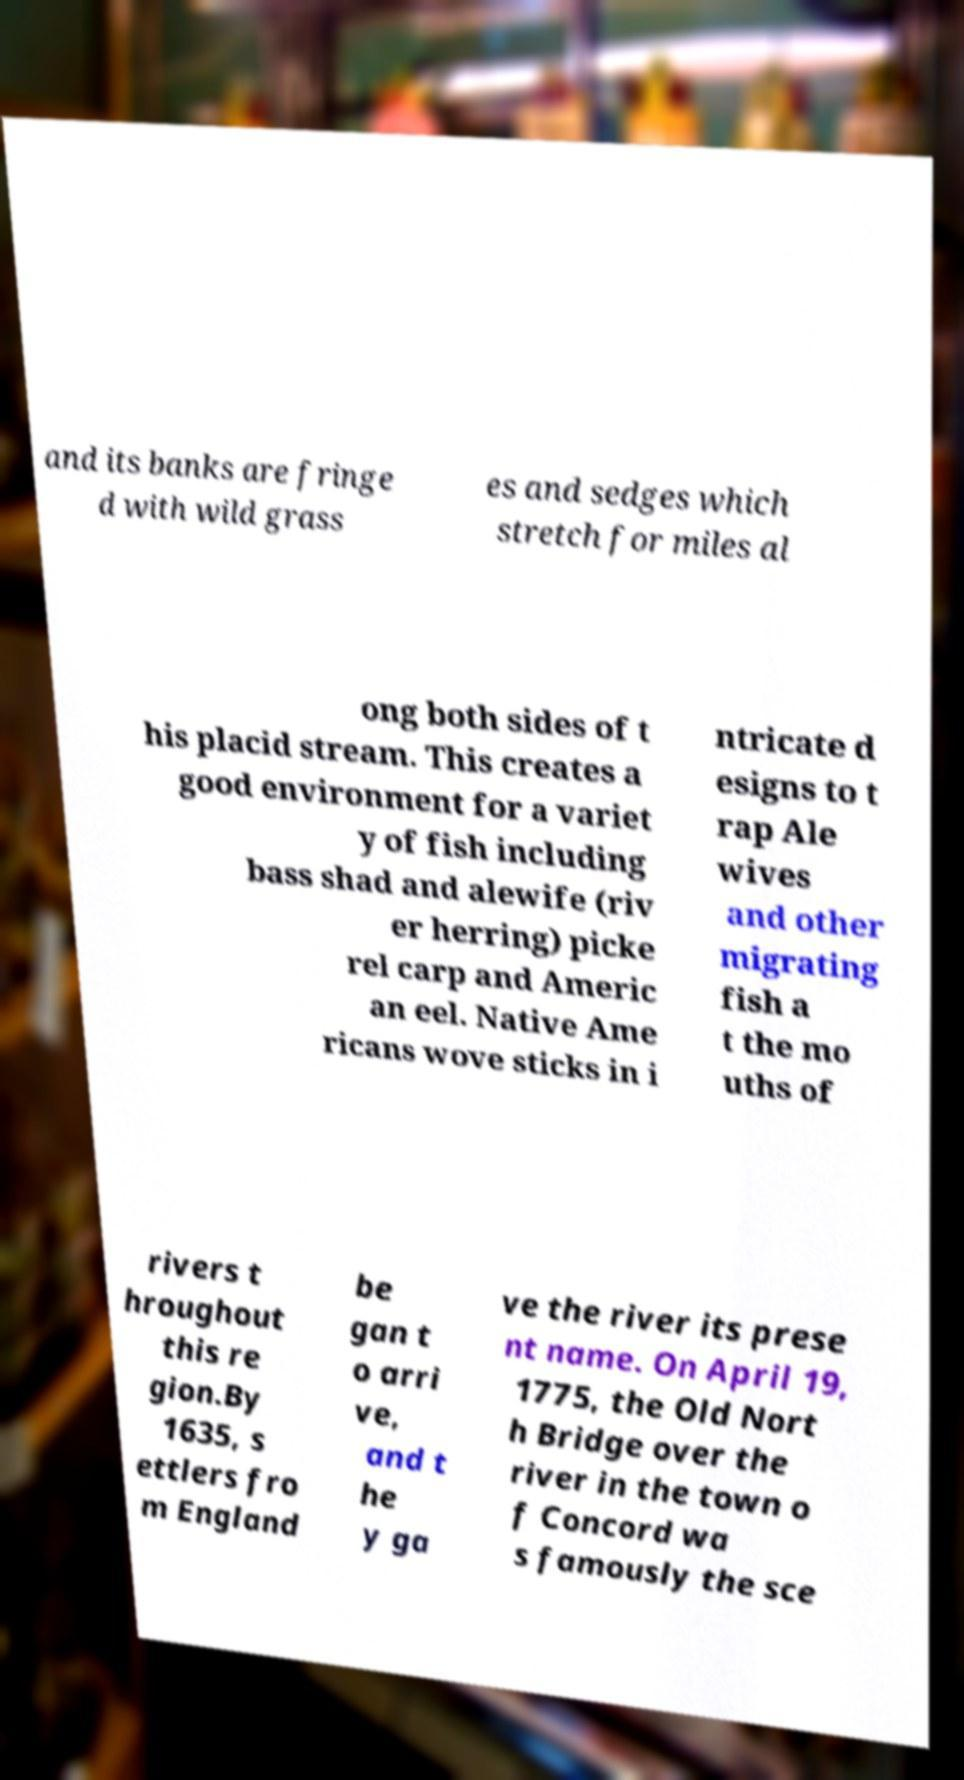Can you accurately transcribe the text from the provided image for me? and its banks are fringe d with wild grass es and sedges which stretch for miles al ong both sides of t his placid stream. This creates a good environment for a variet y of fish including bass shad and alewife (riv er herring) picke rel carp and Americ an eel. Native Ame ricans wove sticks in i ntricate d esigns to t rap Ale wives and other migrating fish a t the mo uths of rivers t hroughout this re gion.By 1635, s ettlers fro m England be gan t o arri ve, and t he y ga ve the river its prese nt name. On April 19, 1775, the Old Nort h Bridge over the river in the town o f Concord wa s famously the sce 